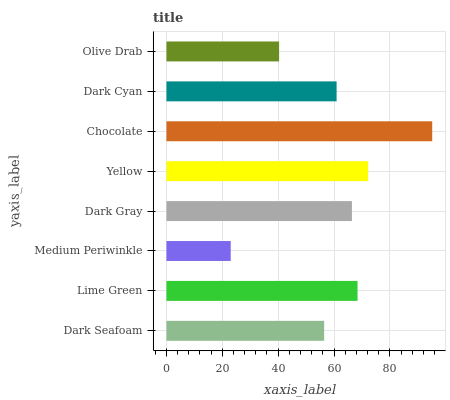Is Medium Periwinkle the minimum?
Answer yes or no. Yes. Is Chocolate the maximum?
Answer yes or no. Yes. Is Lime Green the minimum?
Answer yes or no. No. Is Lime Green the maximum?
Answer yes or no. No. Is Lime Green greater than Dark Seafoam?
Answer yes or no. Yes. Is Dark Seafoam less than Lime Green?
Answer yes or no. Yes. Is Dark Seafoam greater than Lime Green?
Answer yes or no. No. Is Lime Green less than Dark Seafoam?
Answer yes or no. No. Is Dark Gray the high median?
Answer yes or no. Yes. Is Dark Cyan the low median?
Answer yes or no. Yes. Is Dark Seafoam the high median?
Answer yes or no. No. Is Dark Seafoam the low median?
Answer yes or no. No. 